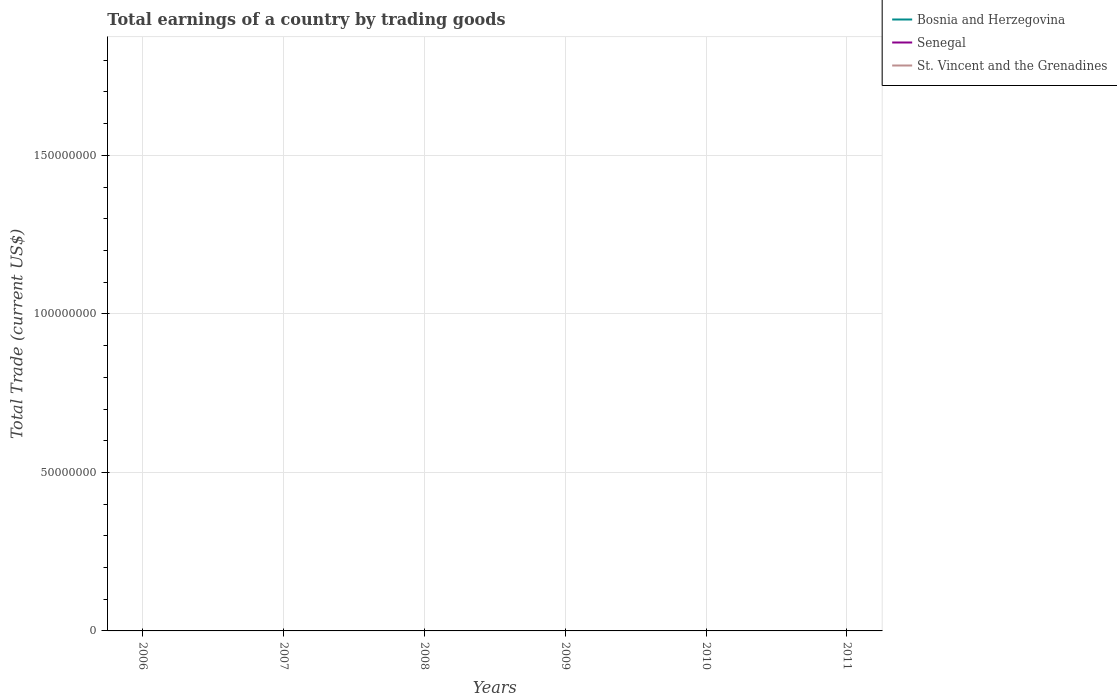How many different coloured lines are there?
Provide a succinct answer. 0. Does the line corresponding to Bosnia and Herzegovina intersect with the line corresponding to Senegal?
Your response must be concise. No. Is the number of lines equal to the number of legend labels?
Offer a terse response. No. Across all years, what is the maximum total earnings in Senegal?
Give a very brief answer. 0. How many lines are there?
Keep it short and to the point. 0. How many years are there in the graph?
Ensure brevity in your answer.  6. What is the difference between two consecutive major ticks on the Y-axis?
Give a very brief answer. 5.00e+07. Does the graph contain any zero values?
Your answer should be compact. Yes. What is the title of the graph?
Your response must be concise. Total earnings of a country by trading goods. What is the label or title of the X-axis?
Ensure brevity in your answer.  Years. What is the label or title of the Y-axis?
Ensure brevity in your answer.  Total Trade (current US$). What is the Total Trade (current US$) in St. Vincent and the Grenadines in 2007?
Make the answer very short. 0. What is the Total Trade (current US$) of Bosnia and Herzegovina in 2008?
Your answer should be compact. 0. What is the Total Trade (current US$) of Senegal in 2008?
Ensure brevity in your answer.  0. What is the Total Trade (current US$) of Senegal in 2010?
Ensure brevity in your answer.  0. What is the Total Trade (current US$) of St. Vincent and the Grenadines in 2010?
Keep it short and to the point. 0. What is the Total Trade (current US$) in Bosnia and Herzegovina in 2011?
Make the answer very short. 0. What is the total Total Trade (current US$) in Bosnia and Herzegovina in the graph?
Your answer should be very brief. 0. What is the total Total Trade (current US$) of Senegal in the graph?
Offer a terse response. 0. What is the average Total Trade (current US$) in Senegal per year?
Ensure brevity in your answer.  0. 